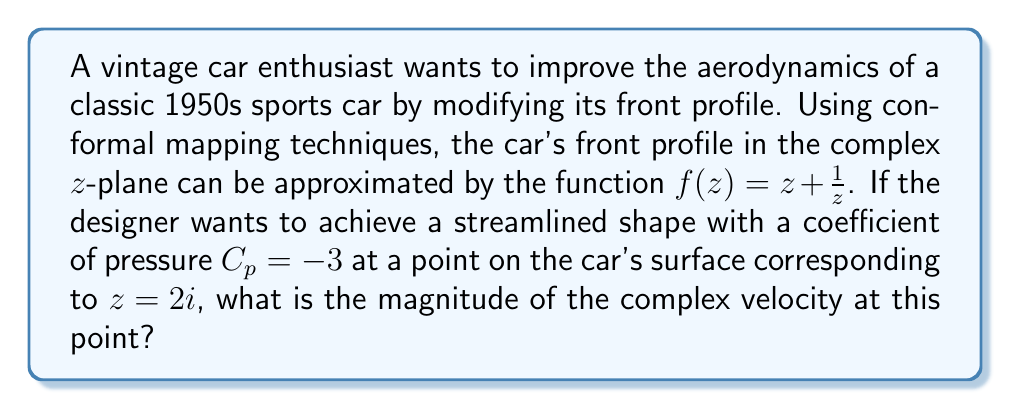Solve this math problem. To solve this problem, we'll follow these steps:

1) In aerodynamics, the coefficient of pressure $C_p$ is related to the velocity by the equation:

   $$C_p = 1 - |\frac{v}{V_\infty}|^2$$

   where $v$ is the local velocity and $V_\infty$ is the freestream velocity.

2) Given $C_p = -3$, we can solve for $|\frac{v}{V_\infty}|$:

   $$-3 = 1 - |\frac{v}{V_\infty}|^2$$
   $$|\frac{v}{V_\infty}|^2 = 4$$
   $$|\frac{v}{V_\infty}| = 2$$

3) In complex potential flow theory, the complex velocity $w$ is given by:

   $$w = \frac{dw}{dz} = \frac{V_\infty}{f'(z)}$$

4) We need to find $f'(z)$:

   $$f(z) = z + \frac{1}{z}$$
   $$f'(z) = 1 - \frac{1}{z^2}$$

5) At $z = 2i$:

   $$f'(2i) = 1 - \frac{1}{(2i)^2} = 1 - \frac{1}{-4} = 1 + \frac{1}{4} = \frac{5}{4}$$

6) Therefore, at $z = 2i$:

   $$w = \frac{V_\infty}{f'(2i)} = \frac{V_\infty}{\frac{5}{4}} = \frac{4V_\infty}{5}$$

7) The magnitude of the complex velocity is:

   $$|w| = |\frac{4V_\infty}{5}| = \frac{4V_\infty}{5}$$

8) From step 2, we know that $|v| = 2V_\infty$. Therefore:

   $$\frac{4V_\infty}{5} = 2V_\infty$$
Answer: $\frac{4V_\infty}{5}$ 